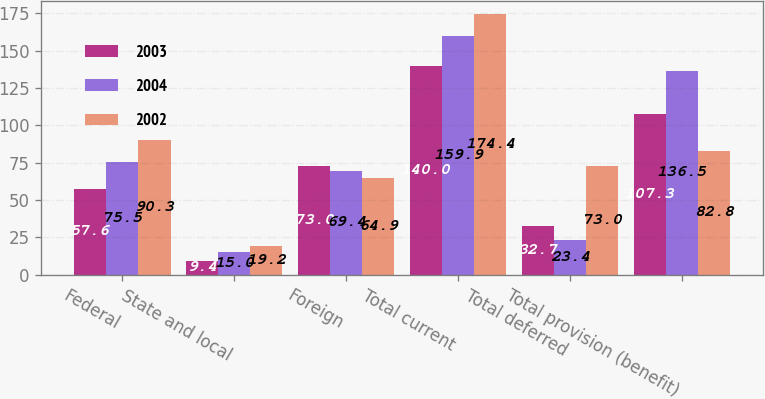<chart> <loc_0><loc_0><loc_500><loc_500><stacked_bar_chart><ecel><fcel>Federal<fcel>State and local<fcel>Foreign<fcel>Total current<fcel>Total deferred<fcel>Total provision (benefit)<nl><fcel>2003<fcel>57.6<fcel>9.4<fcel>73<fcel>140<fcel>32.7<fcel>107.3<nl><fcel>2004<fcel>75.5<fcel>15<fcel>69.4<fcel>159.9<fcel>23.4<fcel>136.5<nl><fcel>2002<fcel>90.3<fcel>19.2<fcel>64.9<fcel>174.4<fcel>73<fcel>82.8<nl></chart> 